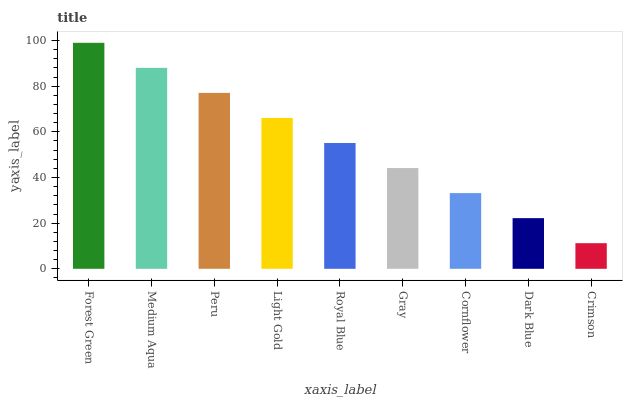Is Crimson the minimum?
Answer yes or no. Yes. Is Forest Green the maximum?
Answer yes or no. Yes. Is Medium Aqua the minimum?
Answer yes or no. No. Is Medium Aqua the maximum?
Answer yes or no. No. Is Forest Green greater than Medium Aqua?
Answer yes or no. Yes. Is Medium Aqua less than Forest Green?
Answer yes or no. Yes. Is Medium Aqua greater than Forest Green?
Answer yes or no. No. Is Forest Green less than Medium Aqua?
Answer yes or no. No. Is Royal Blue the high median?
Answer yes or no. Yes. Is Royal Blue the low median?
Answer yes or no. Yes. Is Dark Blue the high median?
Answer yes or no. No. Is Crimson the low median?
Answer yes or no. No. 